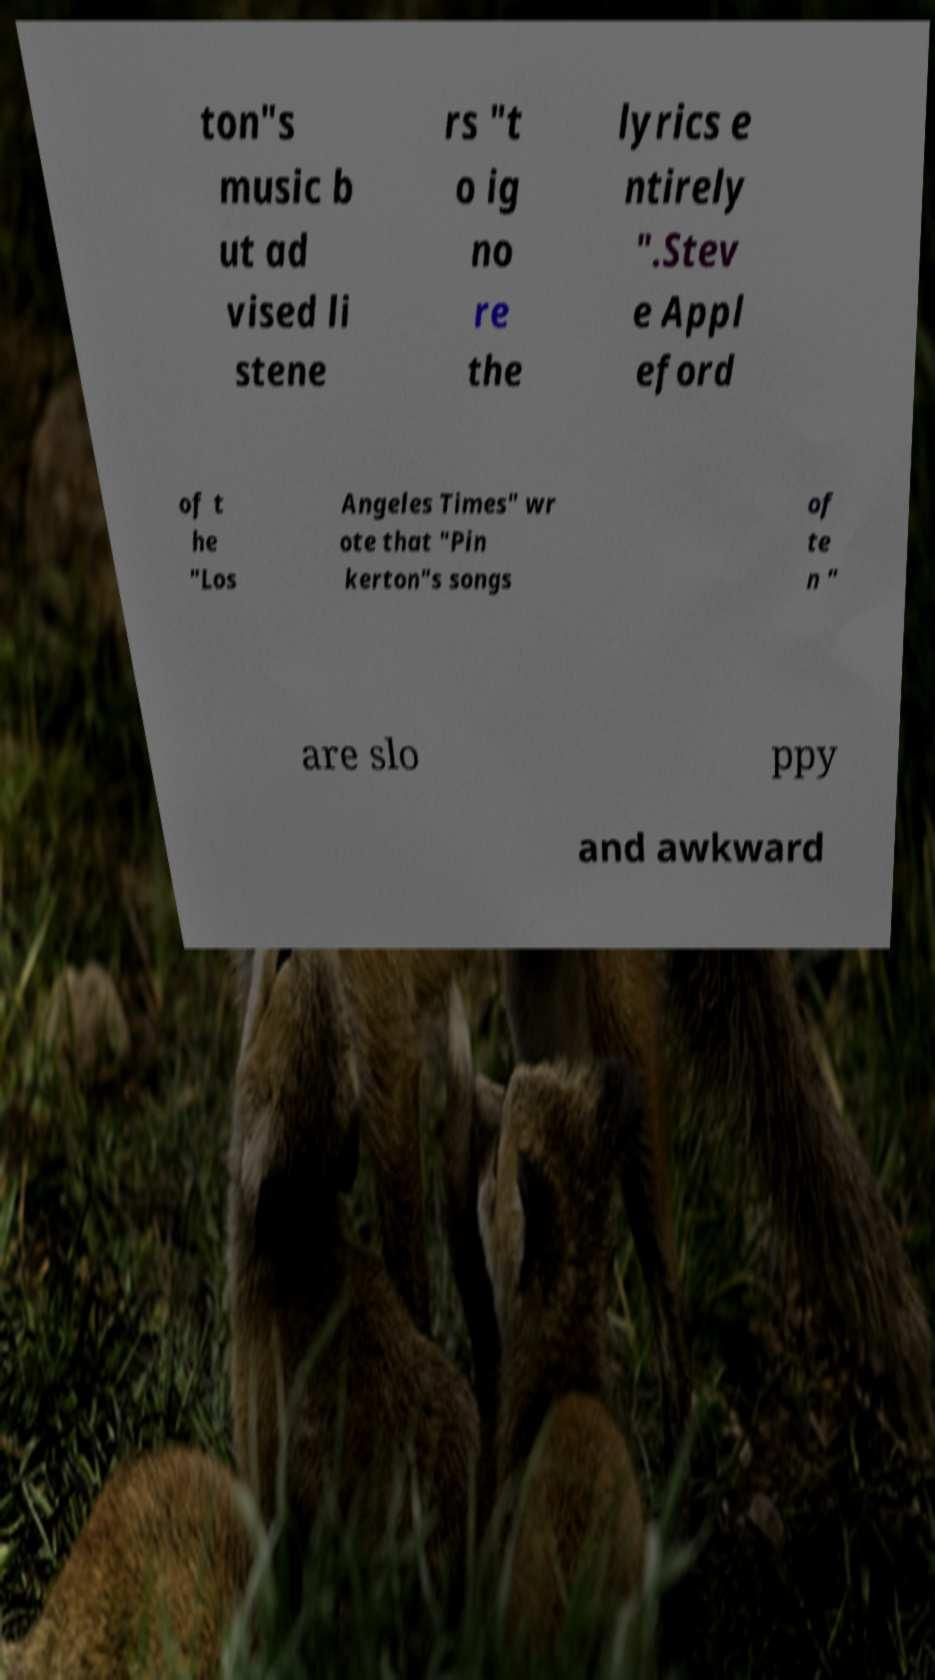For documentation purposes, I need the text within this image transcribed. Could you provide that? ton"s music b ut ad vised li stene rs "t o ig no re the lyrics e ntirely ".Stev e Appl eford of t he "Los Angeles Times" wr ote that "Pin kerton"s songs of te n " are slo ppy and awkward 